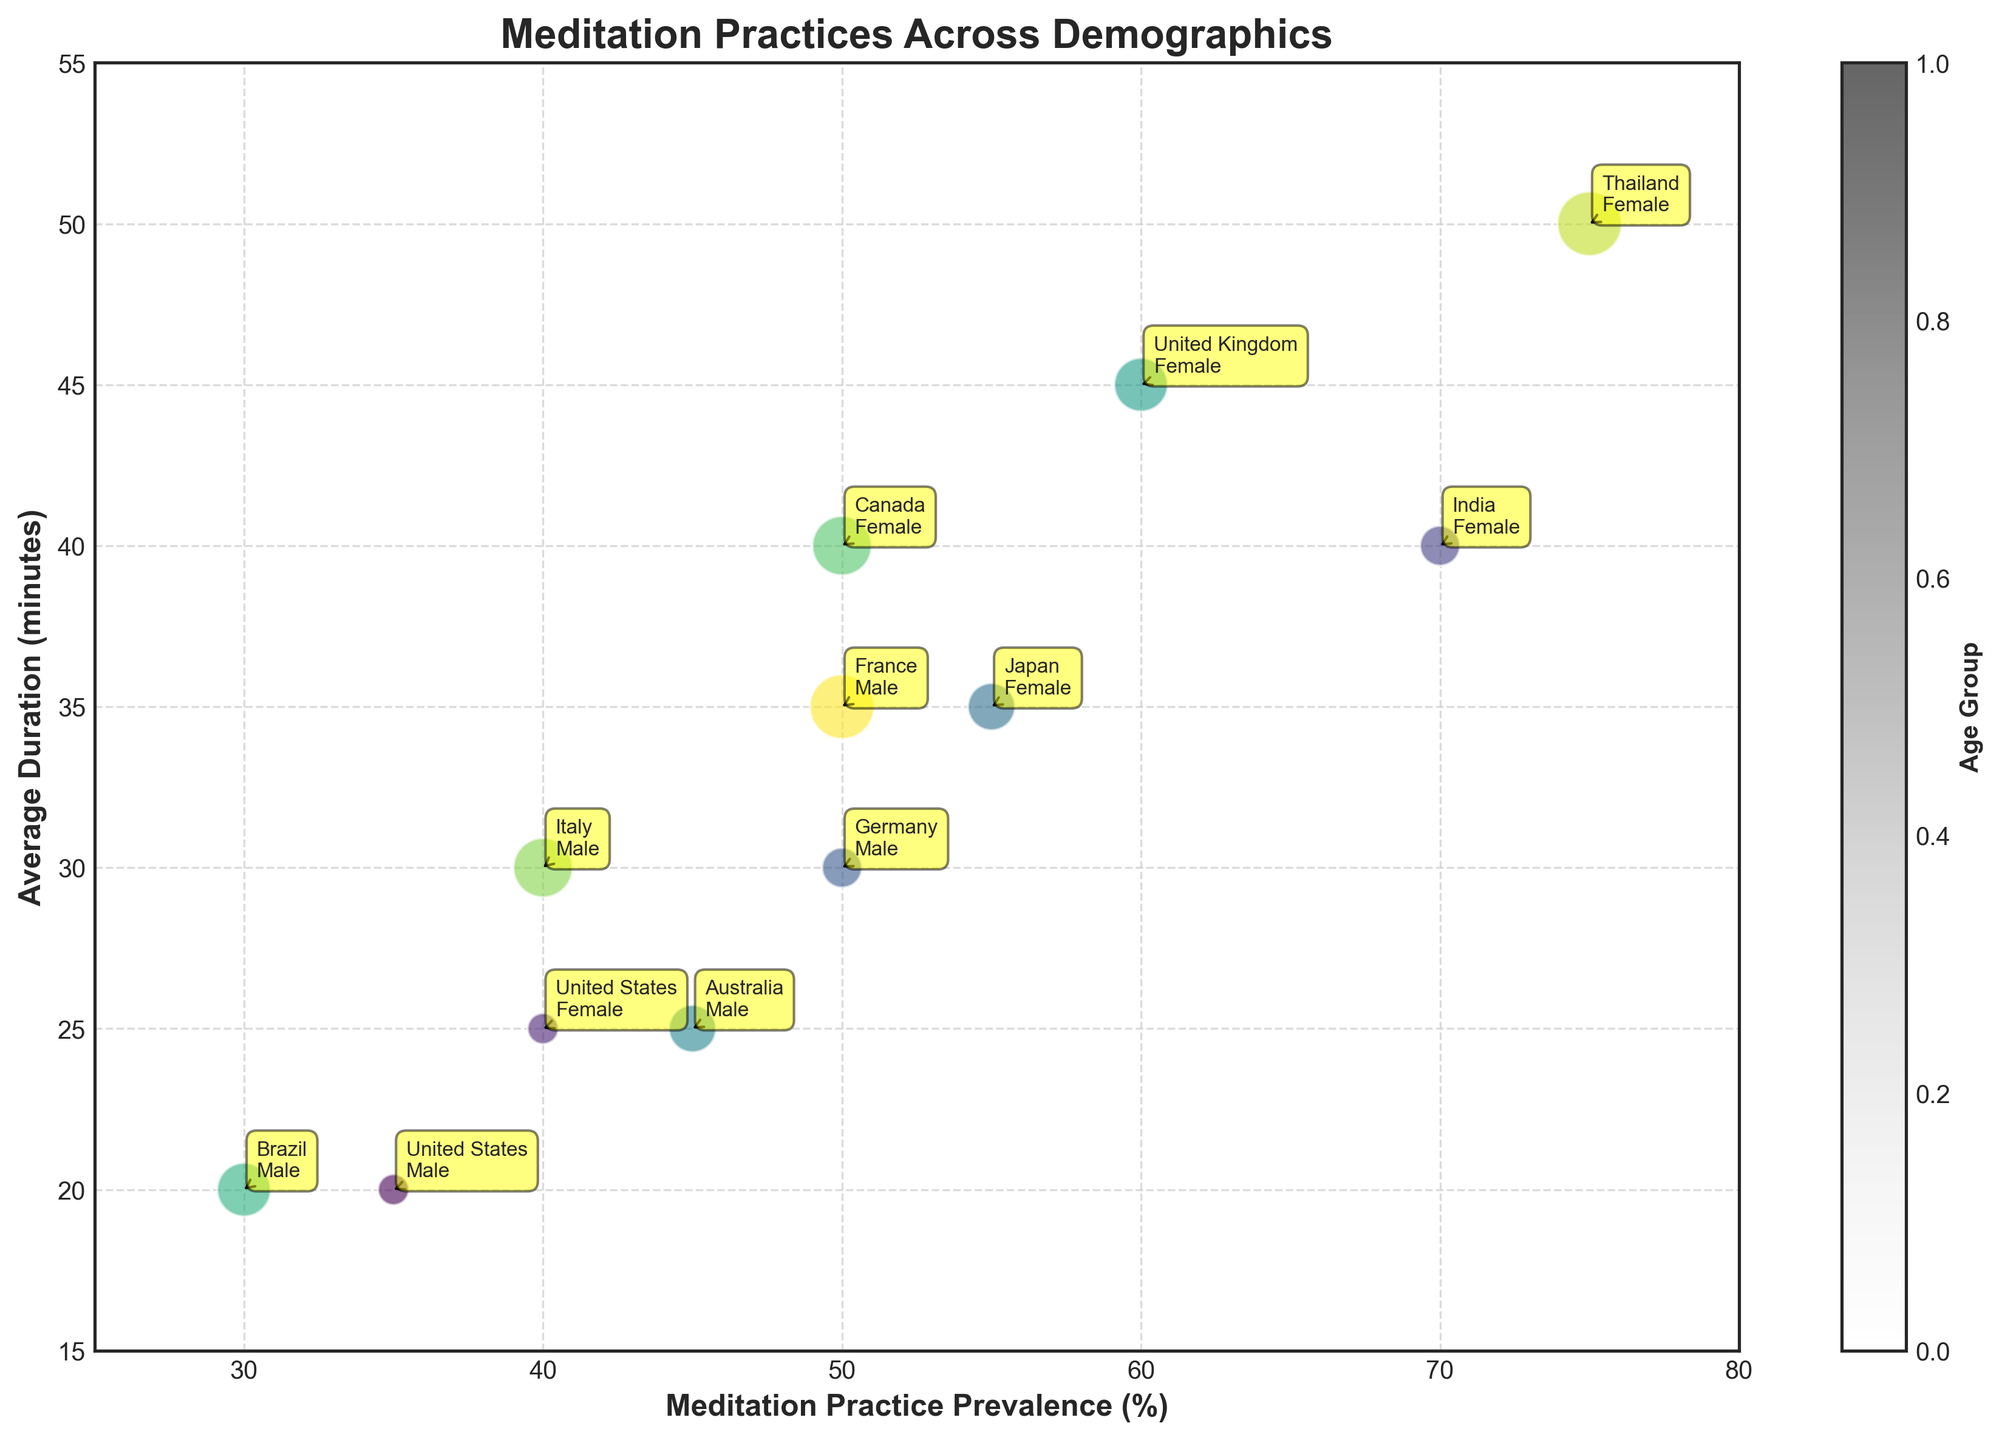What is the title of the plot? The title of the plot is typically displayed at the top of the figure in large, bold font. In this plot, look at the top center for the text that stands out due to its size and boldness.
Answer: Meditation Practices Across Demographics How many data points represent females? Identify the number of bubbles annotated with the text indicating "Female." Count these annotations in the chart. There are data points for Female in the United States (15-24), India (25-34), Japan (35-44), United Kingdom (45-54), Canada (55-64), and Thailand (65+).
Answer: 6 Which age group has the largest bubble size? The bubble size is determined by the age group, with larger sizes indicating older age groups. The oldest age group in the data is 65+, making it the largest. Identify and compare the bubble sizes visually.
Answer: 65+ What is the average meditation practice prevalence (%) across all age groups? Calculate the arithmetic mean of the values in the "Meditation Practice Prevalence (%)" column. Sum all the prevalence values and divide by the number of data points: (35 + 40 + 70 + 50 + 55 + 45 + 60 + 30 + 50 + 40 + 75 + 50) / 12.
Answer: 50 Which demographic group has the highest meditation practice prevalence? Look for the bubble with the highest x-axis value, as the x-axis represents the "Meditation Practice Prevalence (%)". The highest prevalence is 75%, found in the bubble representing Thailand, Female, 65+.
Answer: Thailand, Female, 65+ How does the average duration of meditation practice for 45-54 age groups compare between different countries? Identify the bubbles annotated for the 45-54 age group and compare their y-axis values, which indicate the average duration in minutes. The countries are United Kingdom (Female, 45 minutes) and Brazil (Male, 20 minutes).
Answer: United Kingdom has a higher average duration (45 minutes) compared to Brazil (20 minutes) What is the color bar label indicating? The color bar is a legend that usually indicates an additional variable encoded by the color gradient. In this case, examine the chart to find the label next to the color bar.
Answer: Age Group What is the range of average duration for meditation practices among all demographic groups? Identify the minimum and maximum y-axis values based on the bubbles' positions on the chart. The minimum duration is 20 minutes (United States, Male, 15-24 & Brazil, Male, 45-54), and the maximum is 50 minutes (Thailand, Female, 65+).
Answer: 20 to 50 minutes Which country has a higher average meditation duration, Germany (25-34, Male) or Italy (55-64, Male)? Locate the bubbles representing Germany (Male, 25-34) and Italy (Male, 55-64). Compare their y-axis positions, indicating the average duration in minutes. Germany is at 30 minutes, and Italy is also at 30 minutes.
Answer: Both have the same average duration (30 minutes) 